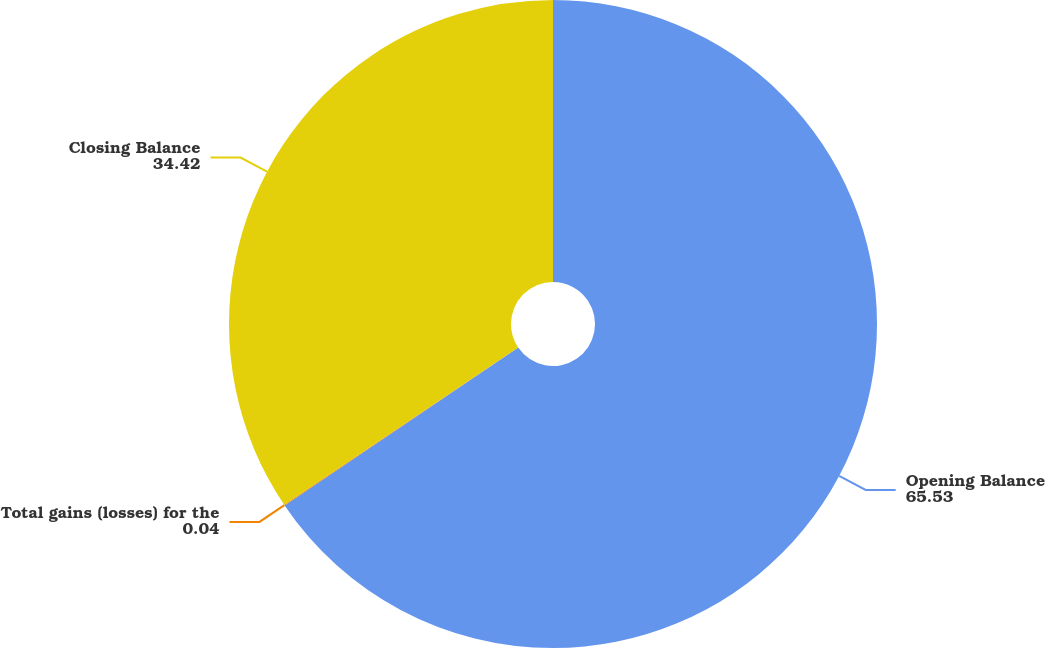Convert chart to OTSL. <chart><loc_0><loc_0><loc_500><loc_500><pie_chart><fcel>Opening Balance<fcel>Total gains (losses) for the<fcel>Closing Balance<nl><fcel>65.53%<fcel>0.04%<fcel>34.42%<nl></chart> 